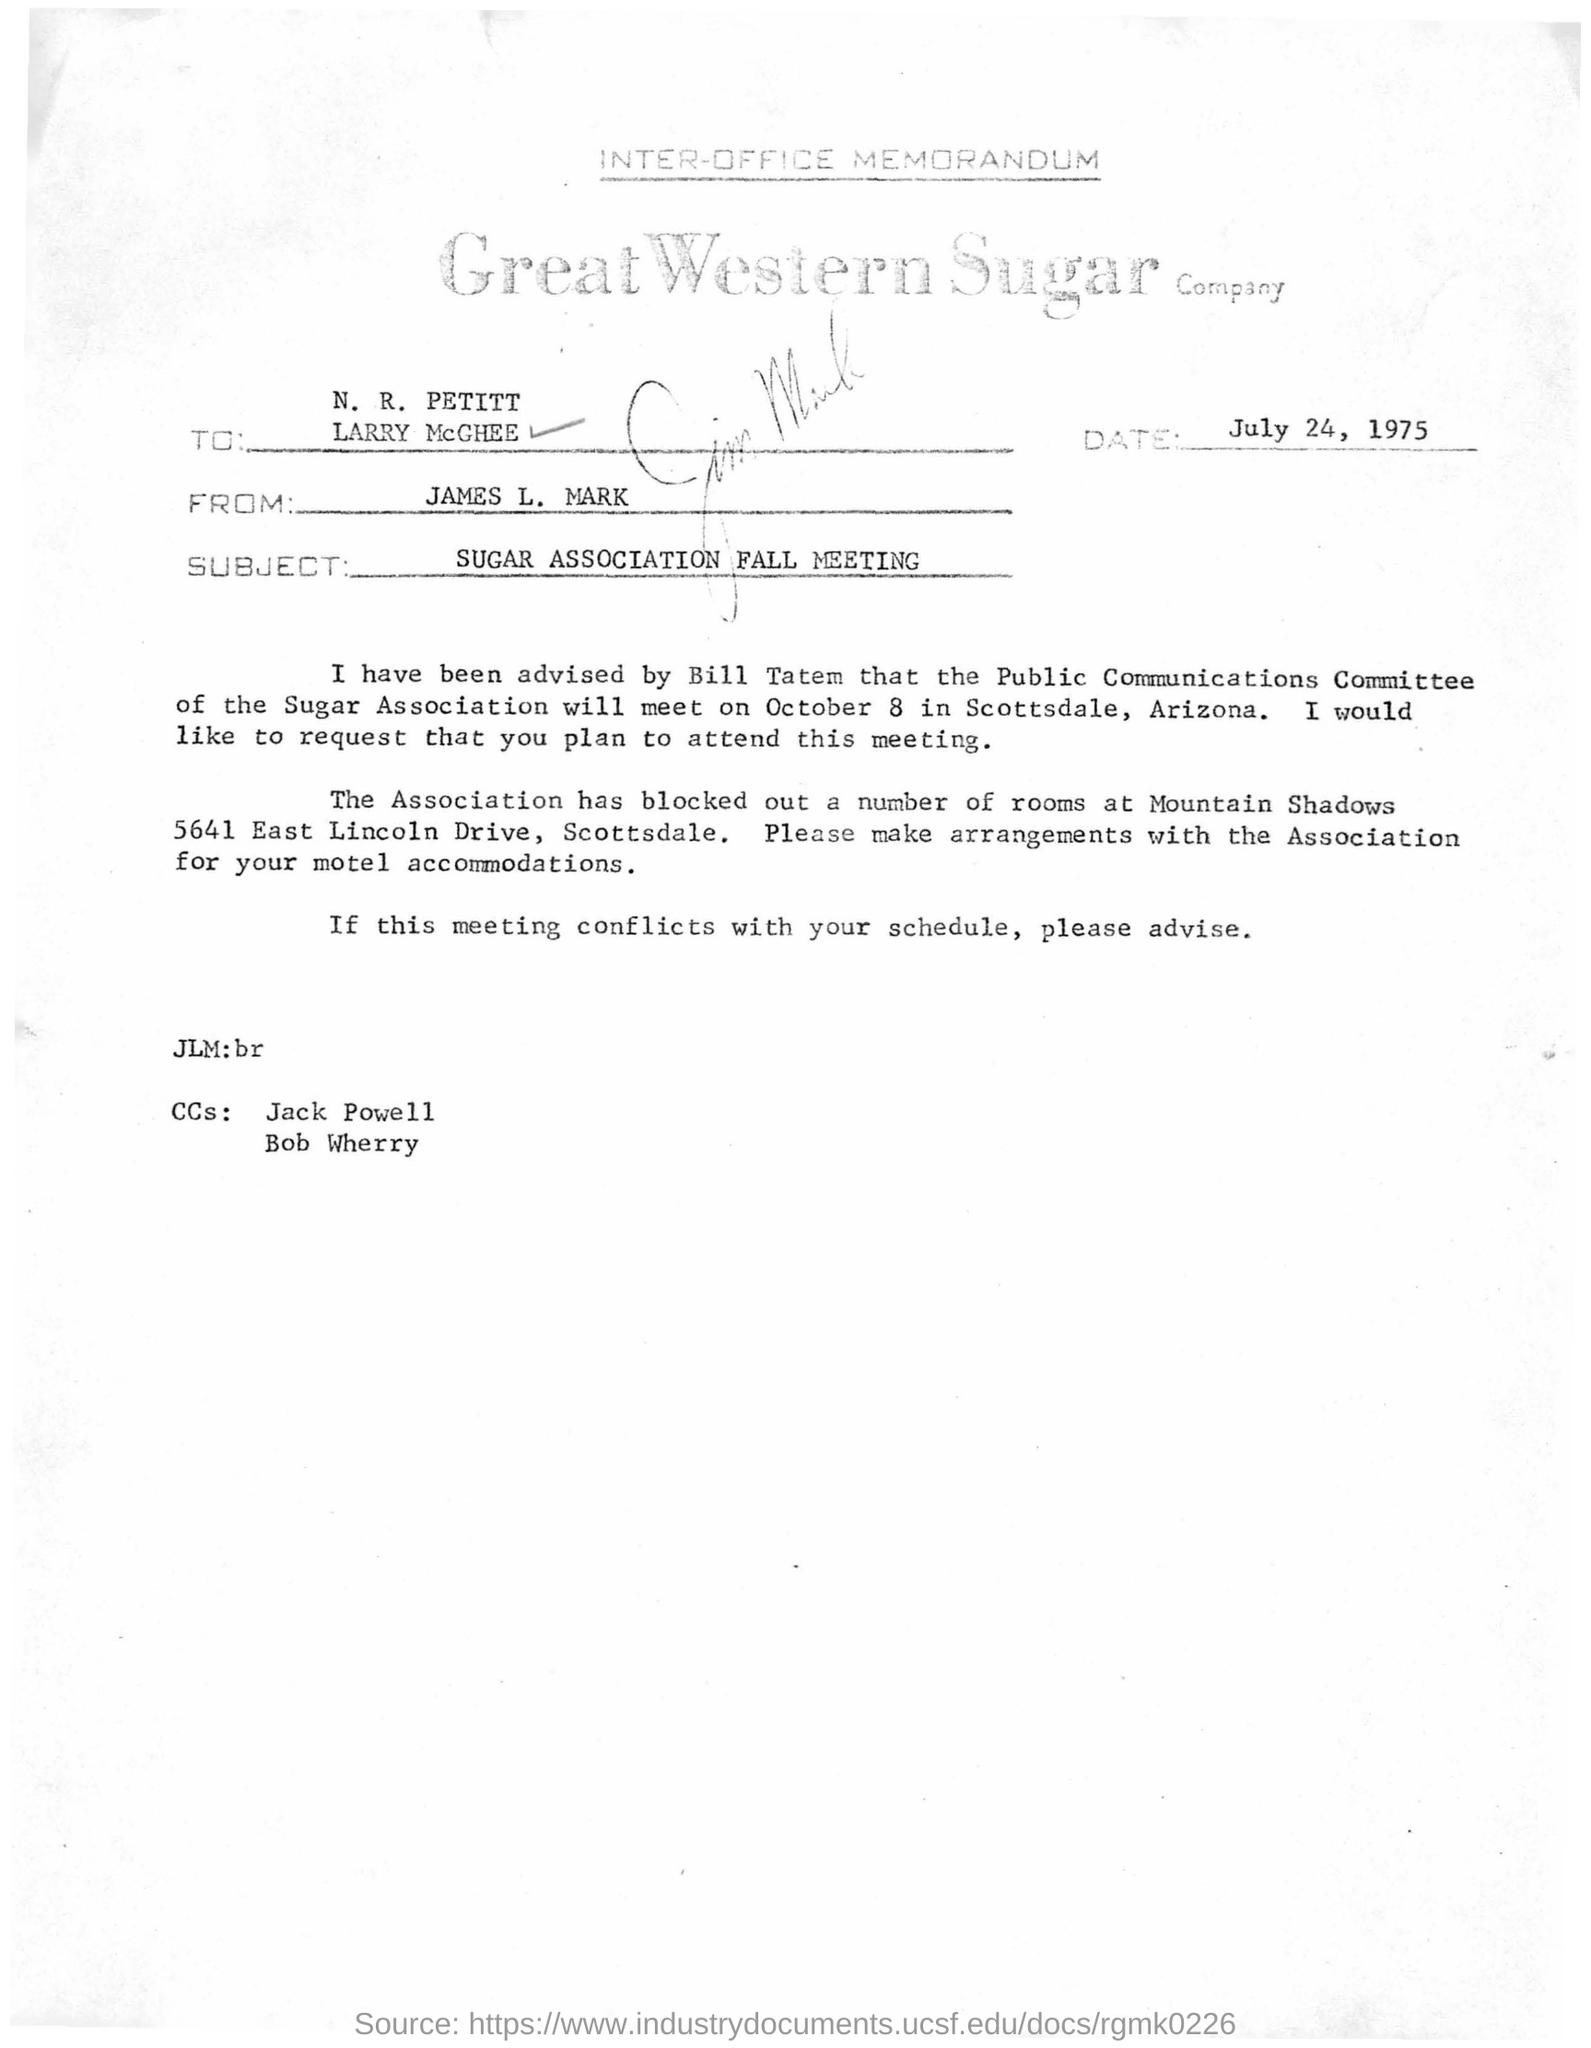Mention a couple of crucial points in this snapshot. The memorandum mentions that the date is July 24, 1975. This is a inter-office memorandum. The memorandum is from James L. Mark. 